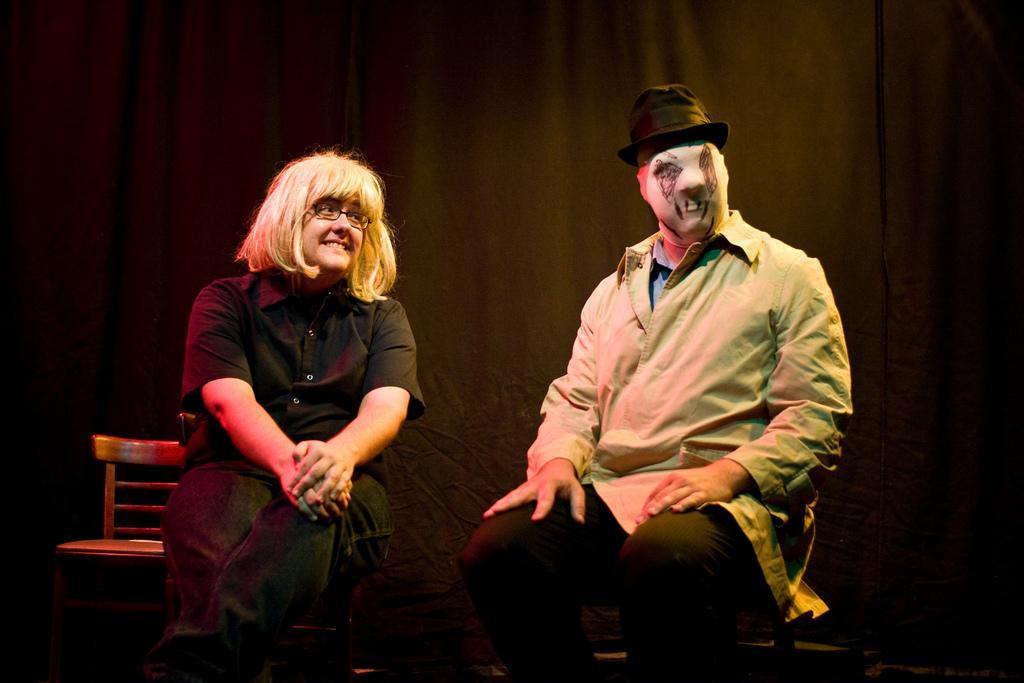How would you summarize this image in a sentence or two? In this image there are two persons sitting on the chairs, there is a person with a mask, and in the background there are curtains and a chair. 